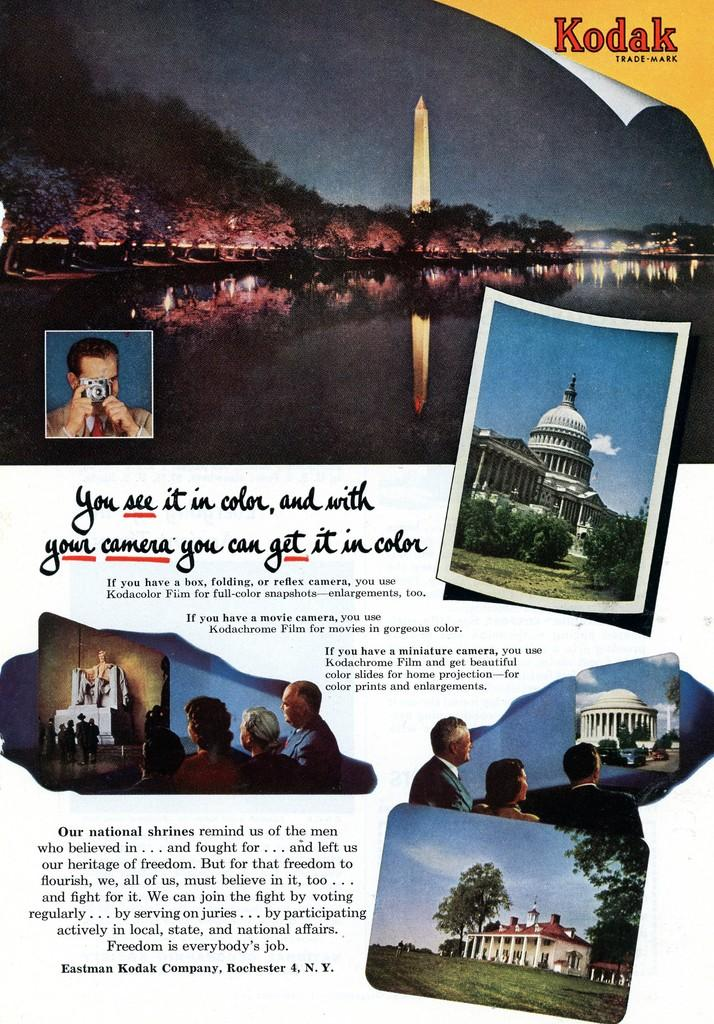What is the main subject of the poster in the image? The poster contains pictures of people, buildings, mountains, rivers, and towers. What type of text is present on the poster? There is text on the poster. Where is the zebra located in the image? There is no zebra present in the image. What type of market is shown in the image? There is no market depicted in the image; the poster contains pictures of people, buildings, mountains, rivers, and towers. 